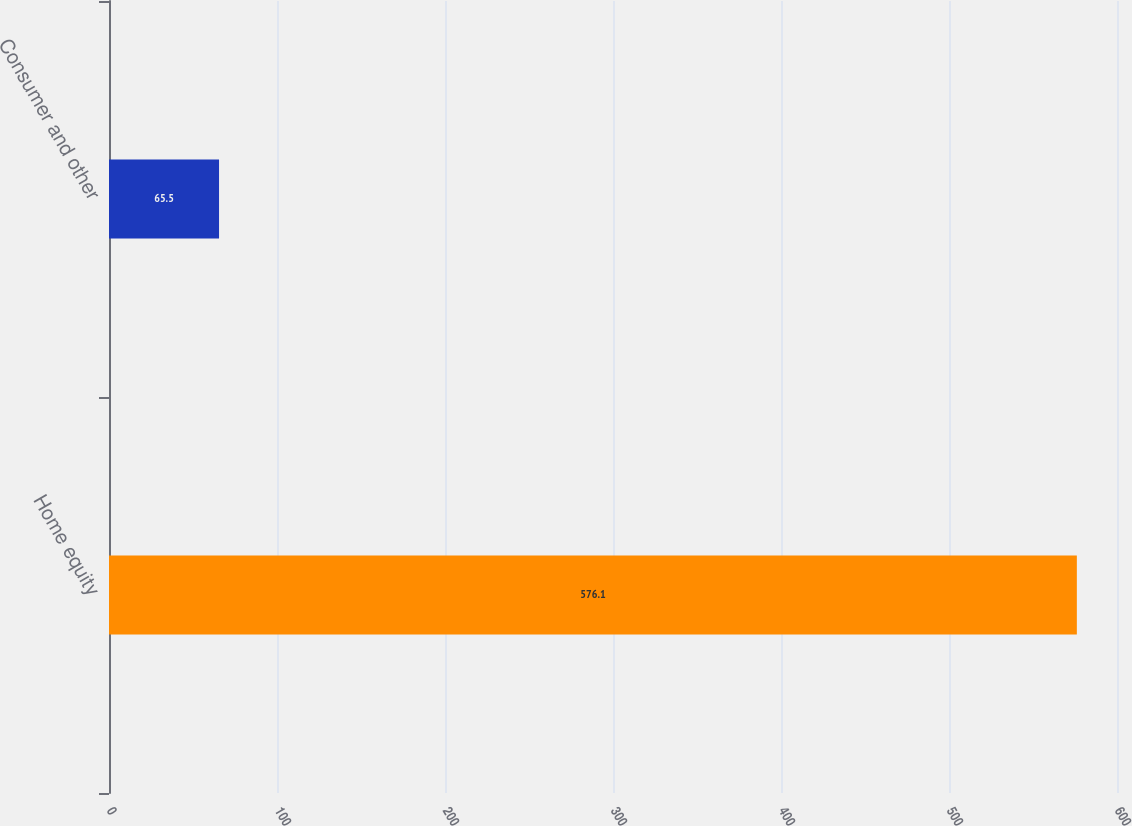Convert chart. <chart><loc_0><loc_0><loc_500><loc_500><bar_chart><fcel>Home equity<fcel>Consumer and other<nl><fcel>576.1<fcel>65.5<nl></chart> 